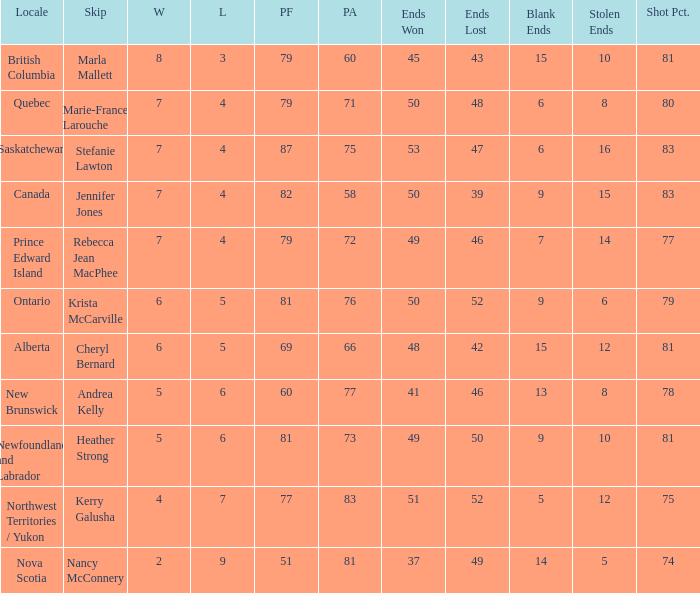Where was the shot pct 78? New Brunswick. 